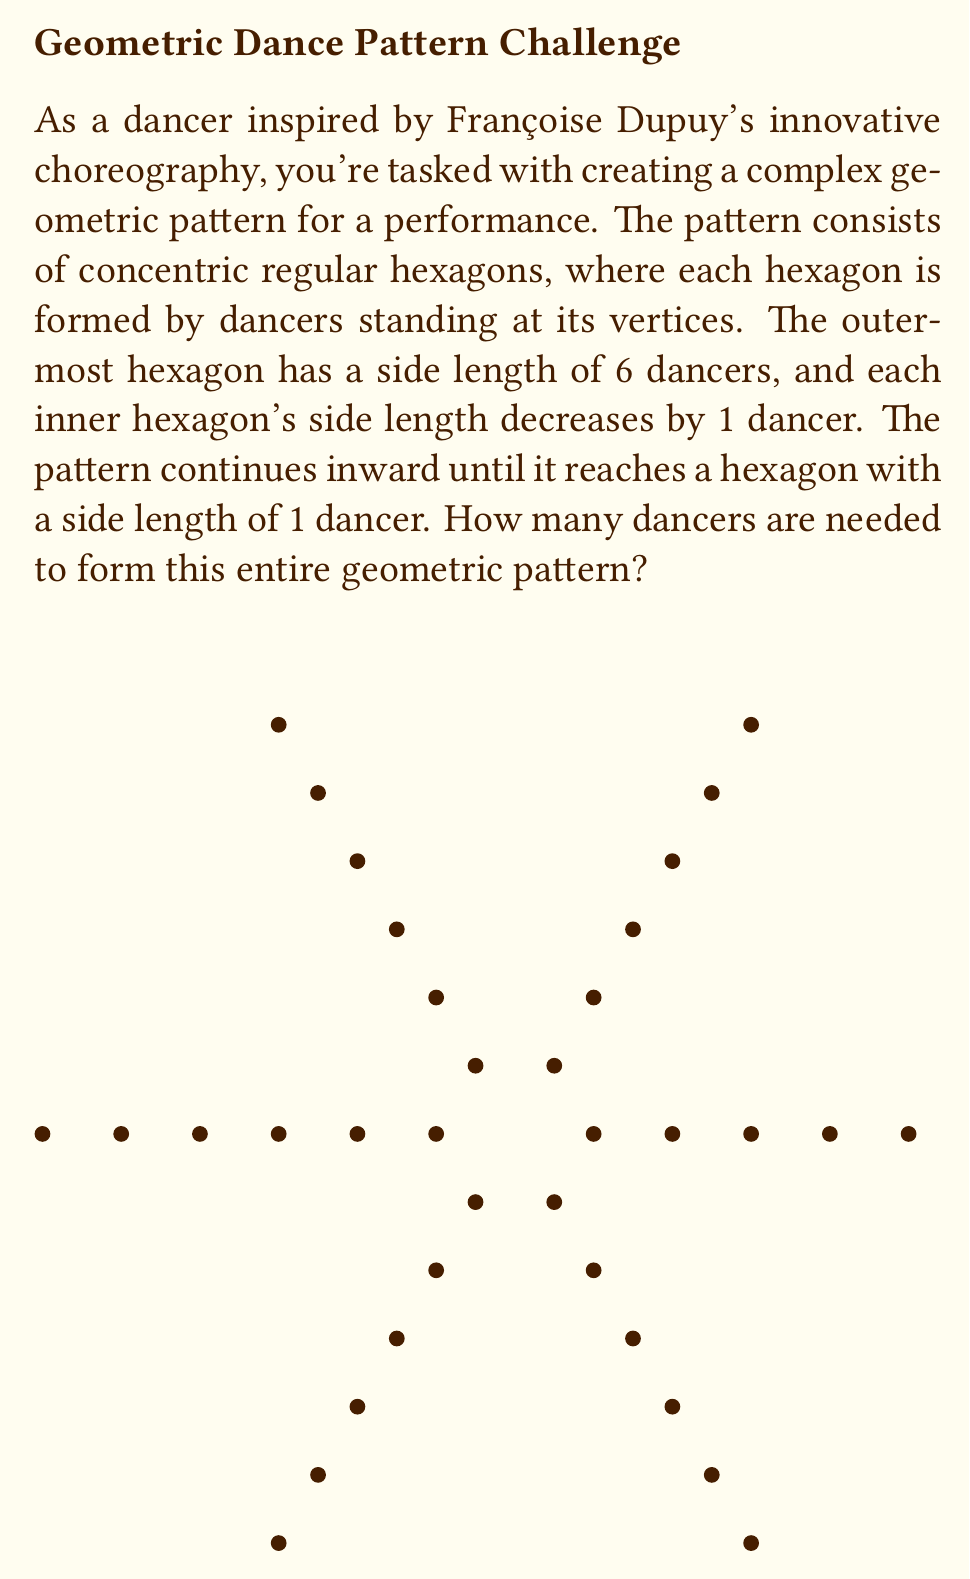Provide a solution to this math problem. Let's approach this step-by-step:

1) First, we need to determine how many hexagons there are in total. Since the outermost hexagon has a side length of 6 dancers, and each inner hexagon decreases by 1 until we reach a side length of 1, there are 6 hexagons in total.

2) Now, let's calculate the number of dancers in each hexagon:
   - Outermost (6th) hexagon: $6 \times 6 = 36$ dancers
   - 5th hexagon: $5 \times 6 = 30$ dancers
   - 4th hexagon: $4 \times 6 = 24$ dancers
   - 3rd hexagon: $3 \times 6 = 18$ dancers
   - 2nd hexagon: $2 \times 6 = 12$ dancers
   - Innermost (1st) hexagon: $1 \times 6 = 6$ dancers

3) To find the total number of dancers, we need to sum these up:

   $$ \text{Total} = 36 + 30 + 24 + 18 + 12 + 6 $$

4) This sum can be represented as an arithmetic sequence:

   $$ S_n = \frac{n}{2}(a_1 + a_n) $$

   Where $n = 6$ (number of terms), $a_1 = 6$ (first term), and $a_n = 36$ (last term)

5) Plugging in these values:

   $$ S_6 = \frac{6}{2}(6 + 36) = 3(42) = 126 $$

Therefore, 126 dancers are needed to form this complex geometric pattern.
Answer: 126 dancers 